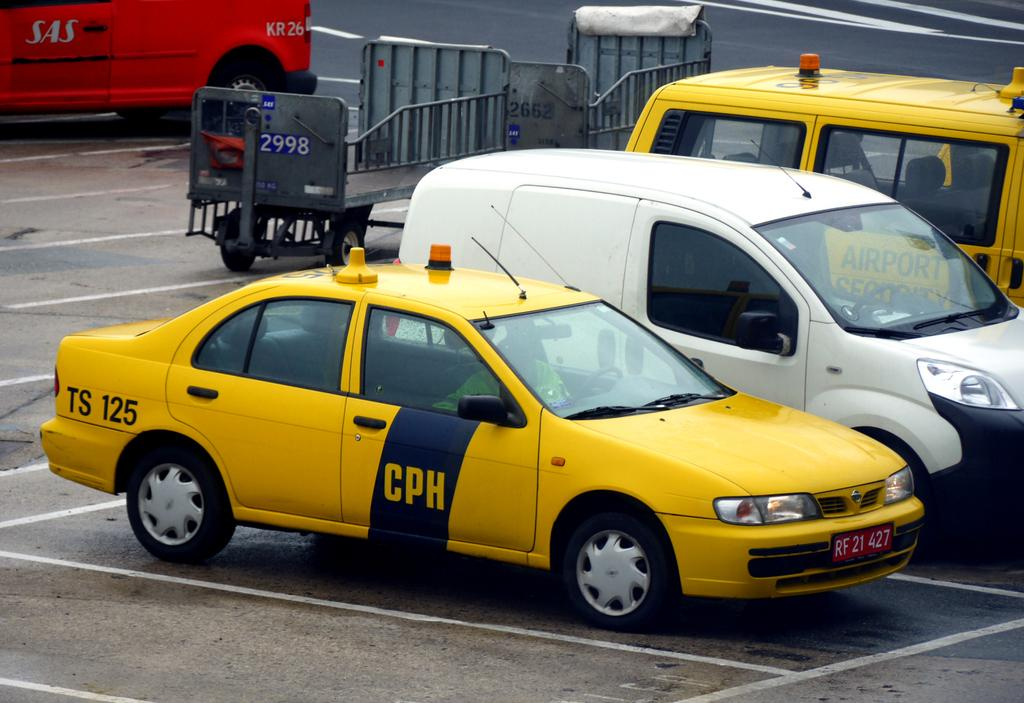<image>
Give a short and clear explanation of the subsequent image. A yellow car that says CPH on its passenger door. 